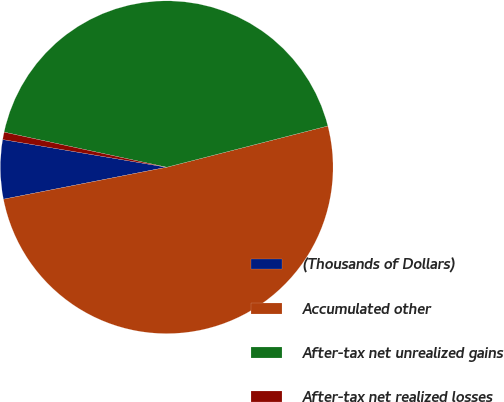Convert chart. <chart><loc_0><loc_0><loc_500><loc_500><pie_chart><fcel>(Thousands of Dollars)<fcel>Accumulated other<fcel>After-tax net unrealized gains<fcel>After-tax net realized losses<nl><fcel>5.74%<fcel>50.91%<fcel>42.62%<fcel>0.72%<nl></chart> 